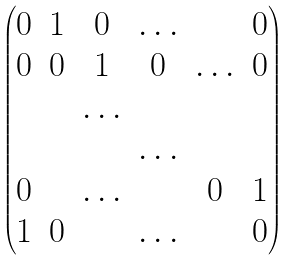<formula> <loc_0><loc_0><loc_500><loc_500>\begin{pmatrix} 0 & 1 & 0 & \hdots & & 0 \\ 0 & 0 & 1 & 0 & \hdots & 0 \\ & & \hdots & & & \\ & & & \hdots & & \\ 0 & & \hdots & & 0 & 1 \\ 1 & 0 & & \hdots & & 0 \end{pmatrix}</formula> 